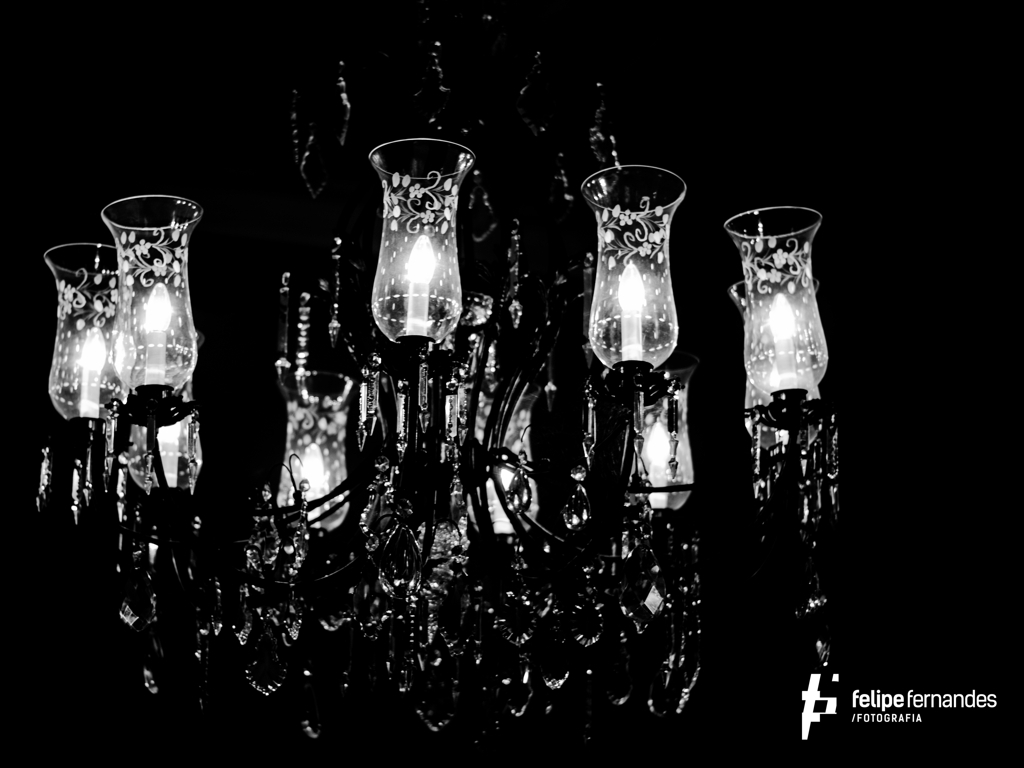How might the photo's monochrome palette influence a viewer's perception? The monochrome palette strips away any distraction from color variation, allowing a viewer to focus on the interplay between light and shadow, the texture, and the details of the chandelier. It evokes a nostalgic and timeless quality, potentially stirring feelings of intrigue and appreciation for the craftsmanship displayed. 